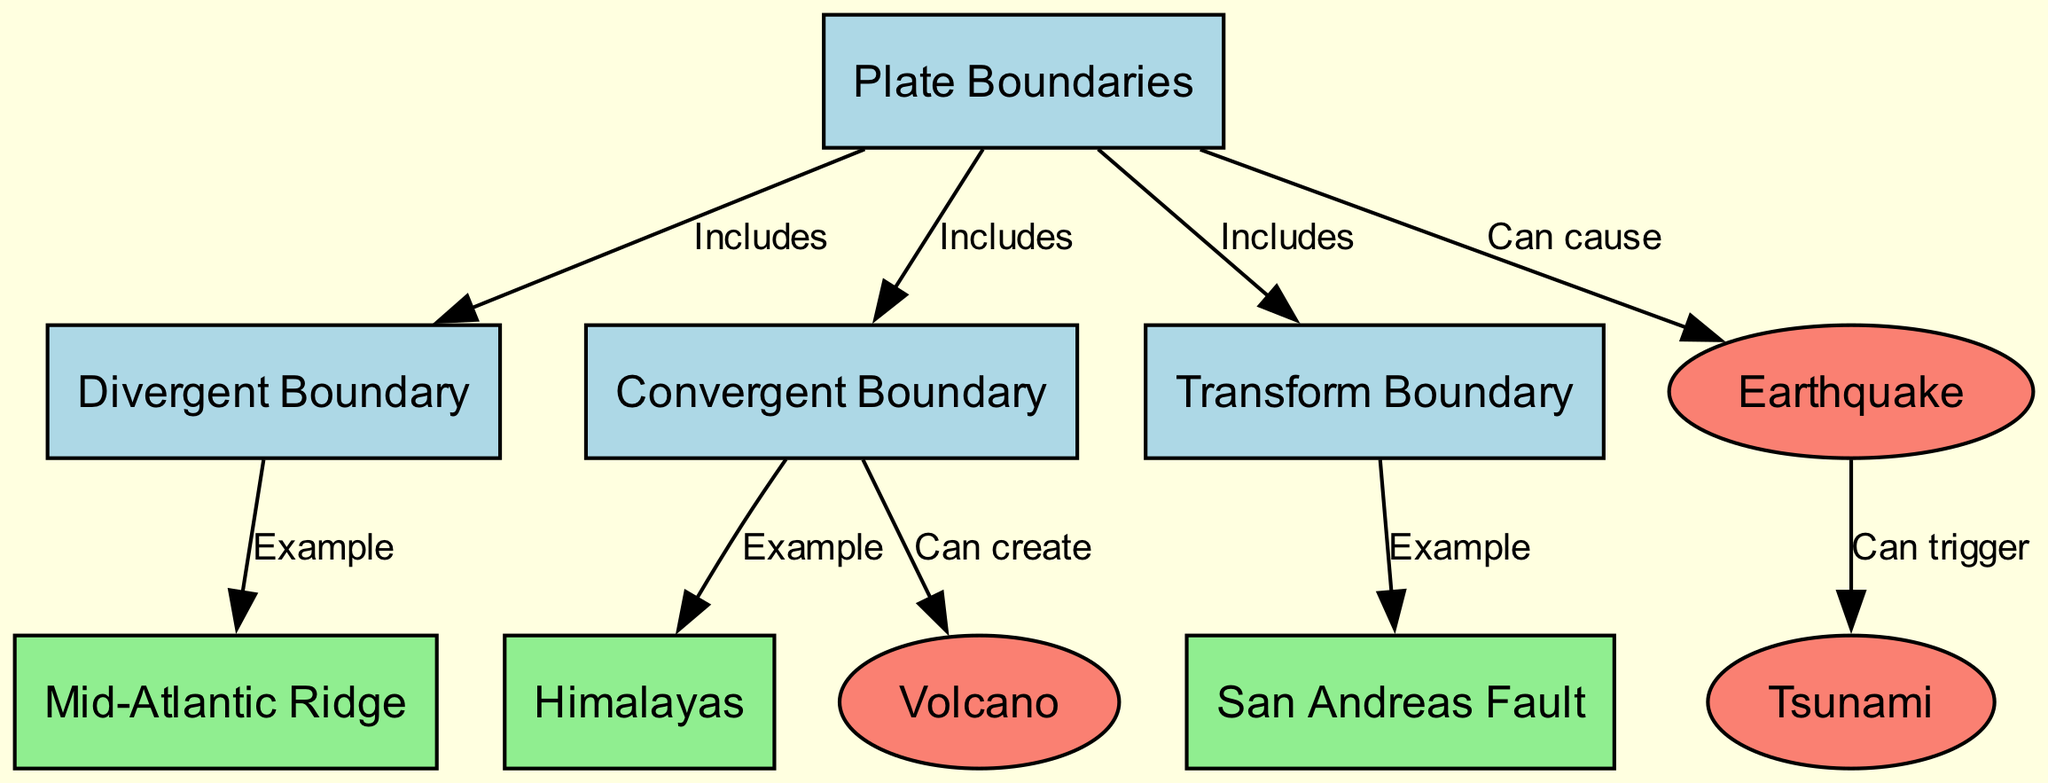What are the three types of plate boundaries? The diagram identifies three types of plate boundaries: divergent, convergent, and transform. These are explicitly labeled and categorized under the node for plate boundaries.
Answer: divergent, convergent, transform Which geological event is caused by sudden plate movements? The diagram connects the concept of earthquakes to sudden plate movements, indicating a direct correlation. This is referenced under the can cause label connecting earthquake to plate boundary.
Answer: earthquake How many examples are provided for boundary types? The diagram lists examples for each boundary type: one for divergent (Mid-Atlantic Ridge), one for convergent (Himalayas), and one for transform (San Andreas Fault), totaling three examples.
Answer: 3 What geological feature can be created by convergent boundaries? The diagram shows a direct link indicating that volcanoes can be created at convergent boundaries, as represented under can create label connecting volcano to convergent boundary.
Answer: volcano What natural disaster can be triggered by an earthquake? The diagram establishes a connection between earthquakes and tsunamis, indicating that tsunamis can be triggered as a result of earthquakes, detailed under can trigger label.
Answer: tsunami How many nodes represent geological activities? The nodes specifically labeled as geological activities are earthquake, volcano, and tsunami, which totals three nodes representing this category.
Answer: 3 Which boundary is an example of a divergent boundary? The diagram specifies the Mid-Atlantic Ridge as an example of a divergent boundary, which is clearly labeled and connected within the diagram's flow.
Answer: Mid-Atlantic Ridge What title encompasses all the movements and activities of Earth's tectonic plates? The overall title of the diagram reflects the collective theme of Earth's tectonic plates, movements, and the resulting geological activities as presented in the graph.
Answer: Earth's Tectonic Plates: Movements and Resulting Geological Activities 